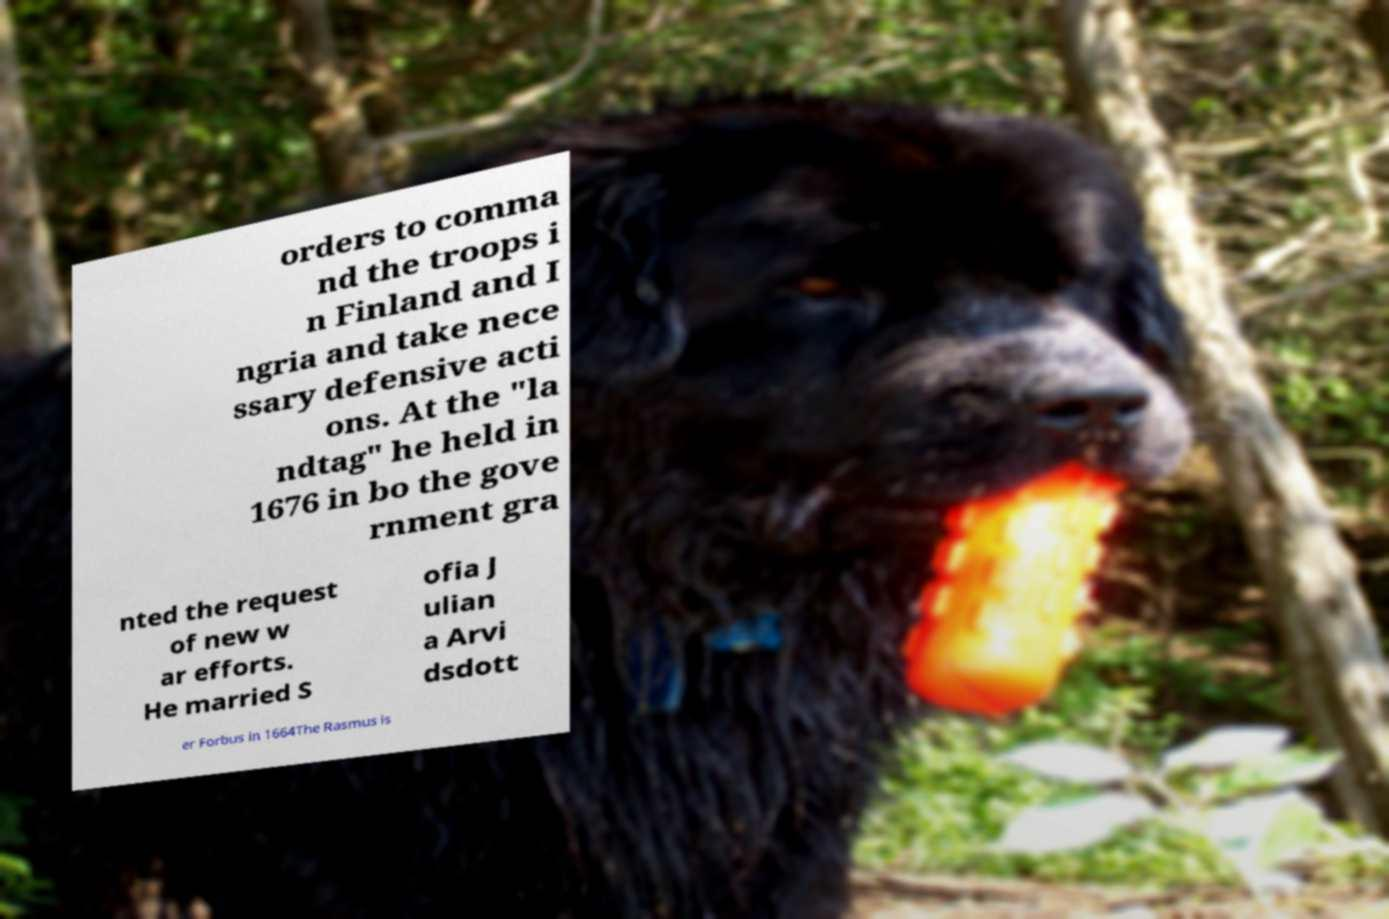There's text embedded in this image that I need extracted. Can you transcribe it verbatim? orders to comma nd the troops i n Finland and I ngria and take nece ssary defensive acti ons. At the "la ndtag" he held in 1676 in bo the gove rnment gra nted the request of new w ar efforts. He married S ofia J ulian a Arvi dsdott er Forbus in 1664The Rasmus is 